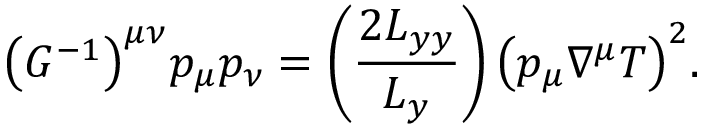Convert formula to latex. <formula><loc_0><loc_0><loc_500><loc_500>\left ( G ^ { - 1 } \right ) ^ { \mu \nu } p _ { \mu } p _ { \nu } = \left ( \frac { 2 L _ { y y } } { L _ { y } } \right ) \left ( p _ { \mu } \nabla ^ { \mu } T \right ) ^ { 2 } .</formula> 